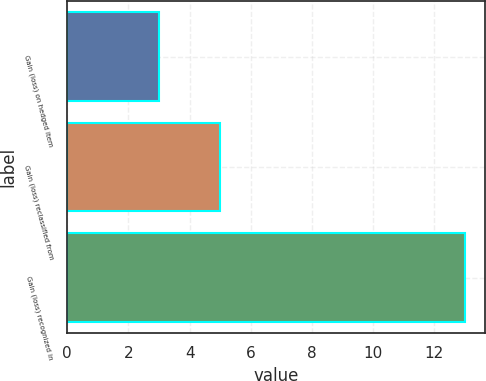Convert chart to OTSL. <chart><loc_0><loc_0><loc_500><loc_500><bar_chart><fcel>Gain (loss) on hedged item<fcel>Gain (loss) reclassified from<fcel>Gain (loss) recognized in<nl><fcel>3<fcel>5<fcel>13<nl></chart> 